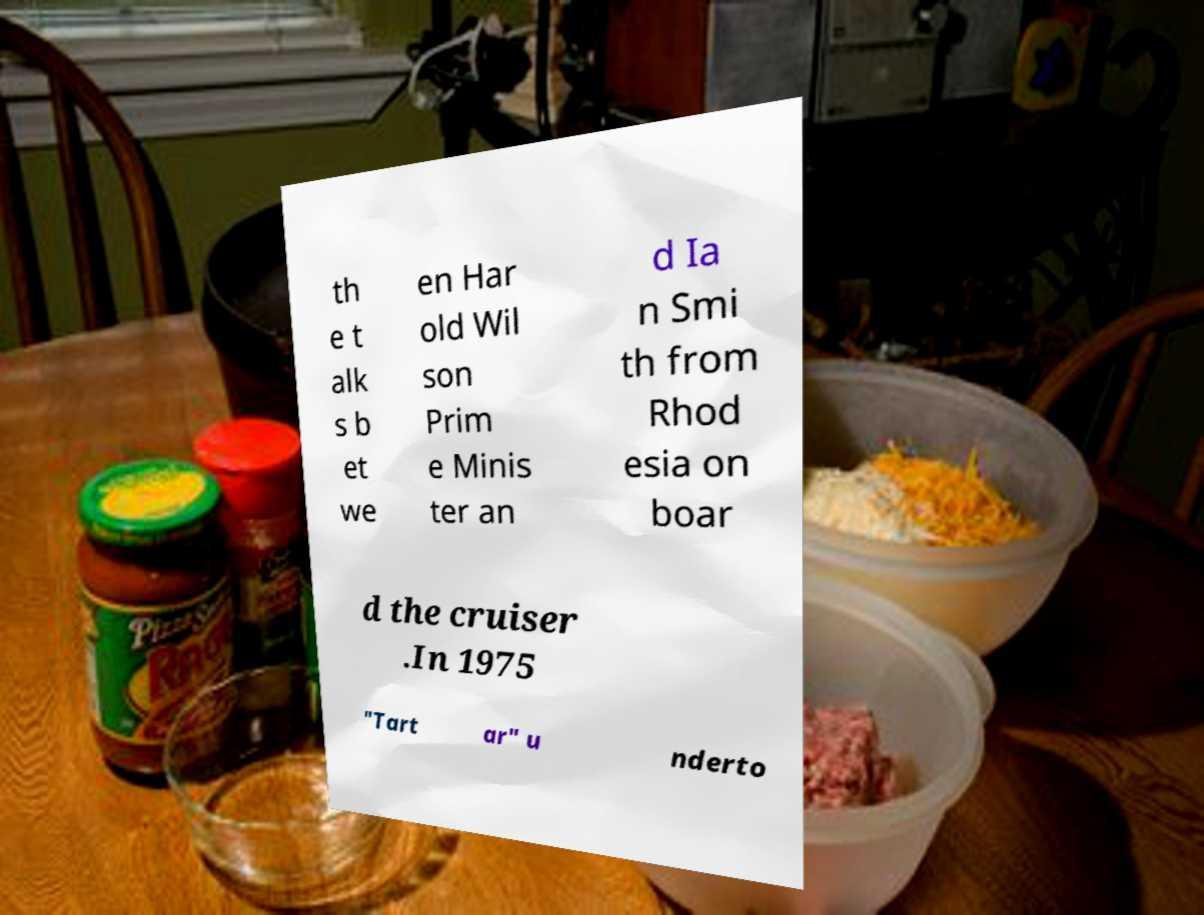What messages or text are displayed in this image? I need them in a readable, typed format. th e t alk s b et we en Har old Wil son Prim e Minis ter an d Ia n Smi th from Rhod esia on boar d the cruiser .In 1975 "Tart ar" u nderto 